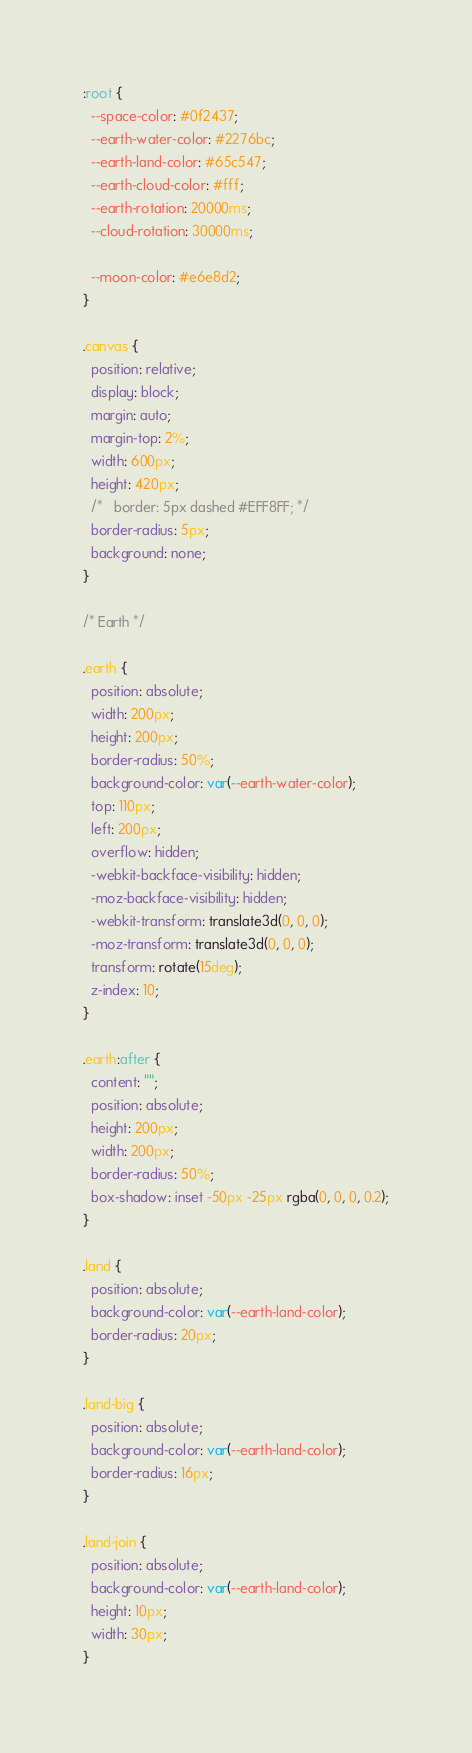Convert code to text. <code><loc_0><loc_0><loc_500><loc_500><_CSS_>:root {
  --space-color: #0f2437;
  --earth-water-color: #2276bc;
  --earth-land-color: #65c547;
  --earth-cloud-color: #fff;
  --earth-rotation: 20000ms;
  --cloud-rotation: 30000ms;

  --moon-color: #e6e8d2;
}

.canvas {
  position: relative;
  display: block;
  margin: auto;
  margin-top: 2%;
  width: 600px;
  height: 420px;
  /*   border: 5px dashed #EFF8FF; */
  border-radius: 5px;
  background: none;
}

/* Earth */

.earth {
  position: absolute;
  width: 200px;
  height: 200px;
  border-radius: 50%;
  background-color: var(--earth-water-color);
  top: 110px;
  left: 200px;
  overflow: hidden;
  -webkit-backface-visibility: hidden;
  -moz-backface-visibility: hidden;
  -webkit-transform: translate3d(0, 0, 0);
  -moz-transform: translate3d(0, 0, 0);
  transform: rotate(15deg);
  z-index: 10;
}

.earth:after {
  content: "";
  position: absolute;
  height: 200px;
  width: 200px;
  border-radius: 50%;
  box-shadow: inset -50px -25px rgba(0, 0, 0, 0.2);
}

.land {
  position: absolute;
  background-color: var(--earth-land-color);
  border-radius: 20px;
}

.land-big {
  position: absolute;
  background-color: var(--earth-land-color);
  border-radius: 16px;
}

.land-join {
  position: absolute;
  background-color: var(--earth-land-color);
  height: 10px;
  width: 30px;
}
</code> 